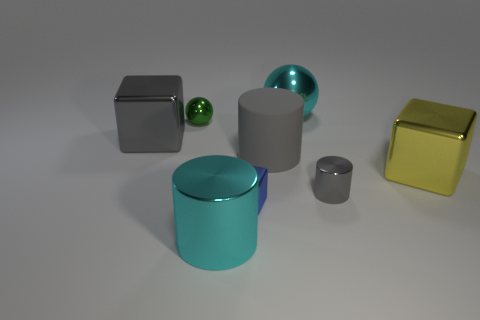Subtract all cyan spheres. How many gray cylinders are left? 2 Subtract all large cylinders. How many cylinders are left? 1 Add 1 green rubber balls. How many objects exist? 9 Subtract all cubes. How many objects are left? 5 Subtract 2 spheres. How many spheres are left? 0 Add 2 small gray things. How many small gray things exist? 3 Subtract 1 gray cylinders. How many objects are left? 7 Subtract all green spheres. Subtract all brown cubes. How many spheres are left? 1 Subtract all gray metal things. Subtract all yellow blocks. How many objects are left? 5 Add 2 small shiny cubes. How many small shiny cubes are left? 3 